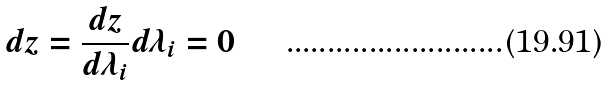Convert formula to latex. <formula><loc_0><loc_0><loc_500><loc_500>d z = \frac { d z } { d \lambda _ { i } } d \lambda _ { i } = 0</formula> 